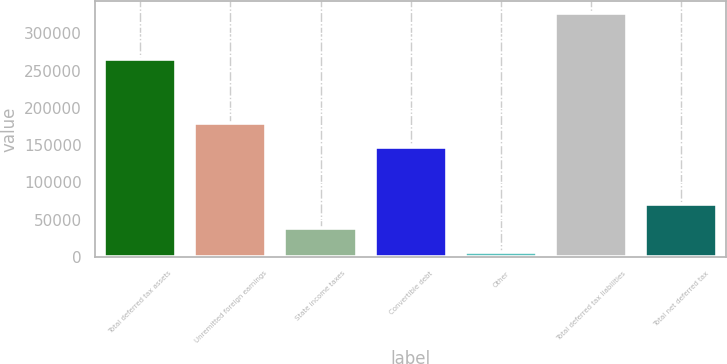Convert chart. <chart><loc_0><loc_0><loc_500><loc_500><bar_chart><fcel>Total deferred tax assets<fcel>Unremitted foreign earnings<fcel>State income taxes<fcel>Convertible debt<fcel>Other<fcel>Total deferred tax liabilities<fcel>Total net deferred tax<nl><fcel>265101<fcel>179962<fcel>38253.9<fcel>147856<fcel>6148<fcel>327207<fcel>70359.8<nl></chart> 